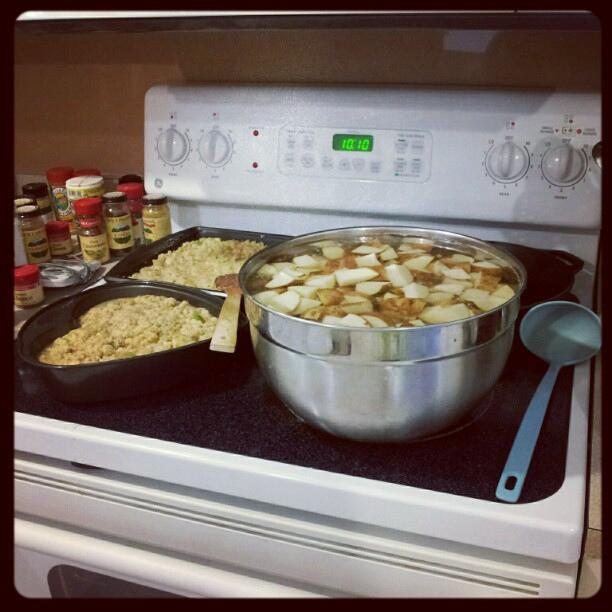Storing the items in the water prevents them from what? Please explain your reasoning. changing color. Cooking the potato's kills any bacteria growth on the vegetable. 